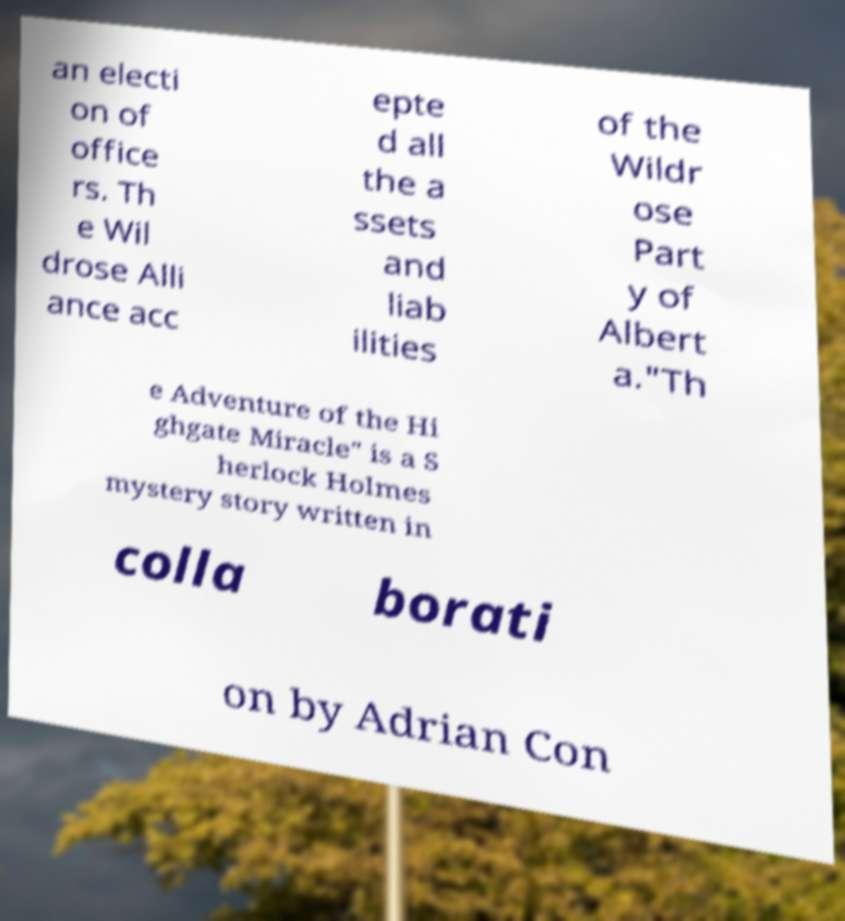Please read and relay the text visible in this image. What does it say? an electi on of office rs. Th e Wil drose Alli ance acc epte d all the a ssets and liab ilities of the Wildr ose Part y of Albert a."Th e Adventure of the Hi ghgate Miracle" is a S herlock Holmes mystery story written in colla borati on by Adrian Con 